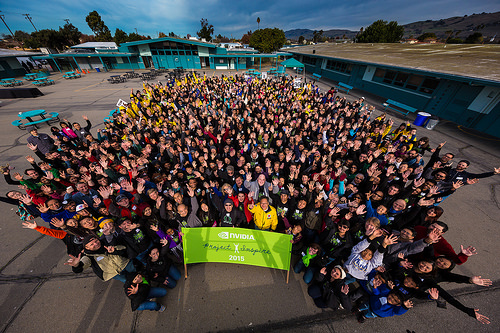<image>
Can you confirm if the woman is to the right of the man? Yes. From this viewpoint, the woman is positioned to the right side relative to the man. 